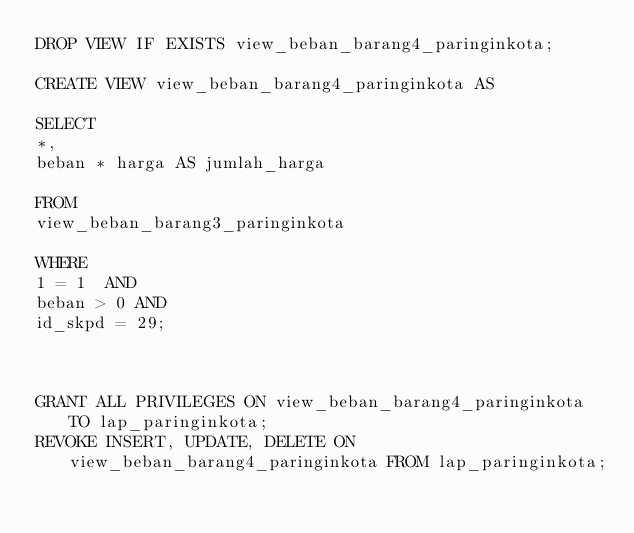Convert code to text. <code><loc_0><loc_0><loc_500><loc_500><_SQL_>DROP VIEW IF EXISTS view_beban_barang4_paringinkota;

CREATE VIEW view_beban_barang4_paringinkota AS

SELECT
*,
beban * harga AS jumlah_harga

FROM
view_beban_barang3_paringinkota

WHERE
1 = 1  AND
beban > 0 AND
id_skpd = 29;



GRANT ALL PRIVILEGES ON view_beban_barang4_paringinkota TO lap_paringinkota;
REVOKE INSERT, UPDATE, DELETE ON view_beban_barang4_paringinkota FROM lap_paringinkota;
</code> 